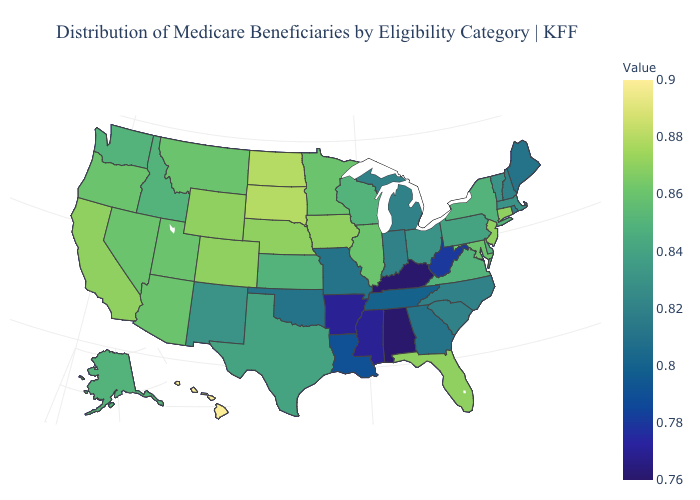Is the legend a continuous bar?
Be succinct. Yes. Does Vermont have a higher value than Hawaii?
Be succinct. No. Which states have the lowest value in the South?
Write a very short answer. Alabama, Kentucky. Does the map have missing data?
Answer briefly. No. Which states hav the highest value in the South?
Answer briefly. Florida. 